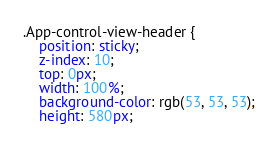<code> <loc_0><loc_0><loc_500><loc_500><_CSS_>.App-control-view-header {
    position: sticky;
    z-index: 10;
    top: 0px;
    width: 100%;
    background-color: rgb(53, 53, 53);
    height: 580px;</code> 